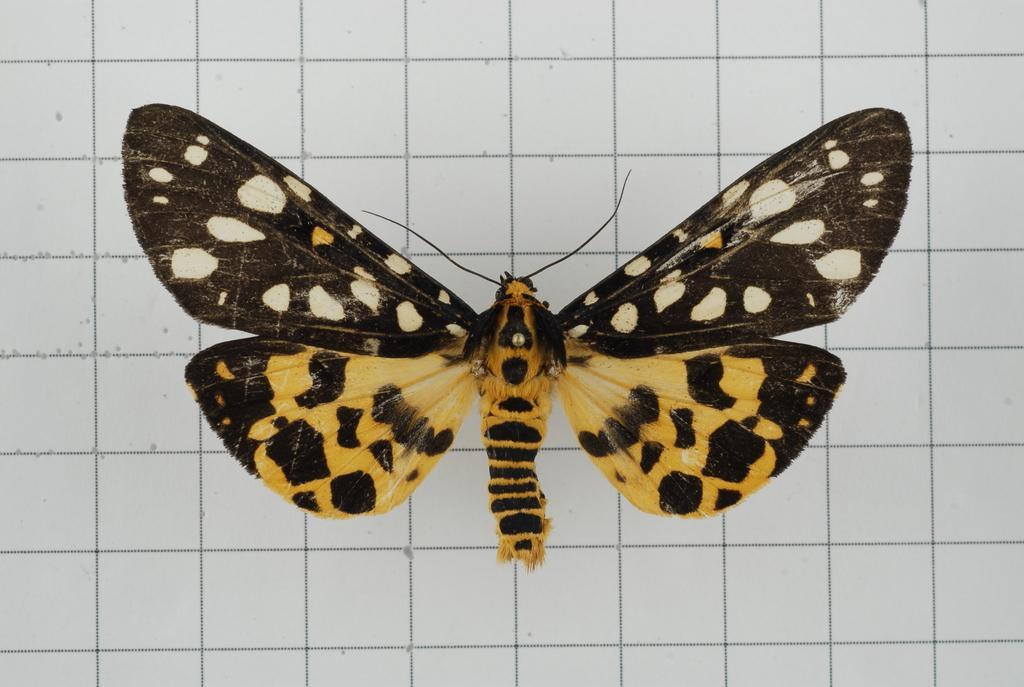In one or two sentences, can you explain what this image depicts? This is a zoomed in picture. In the center there is a butterfly on a white color object seems to be the wall. 